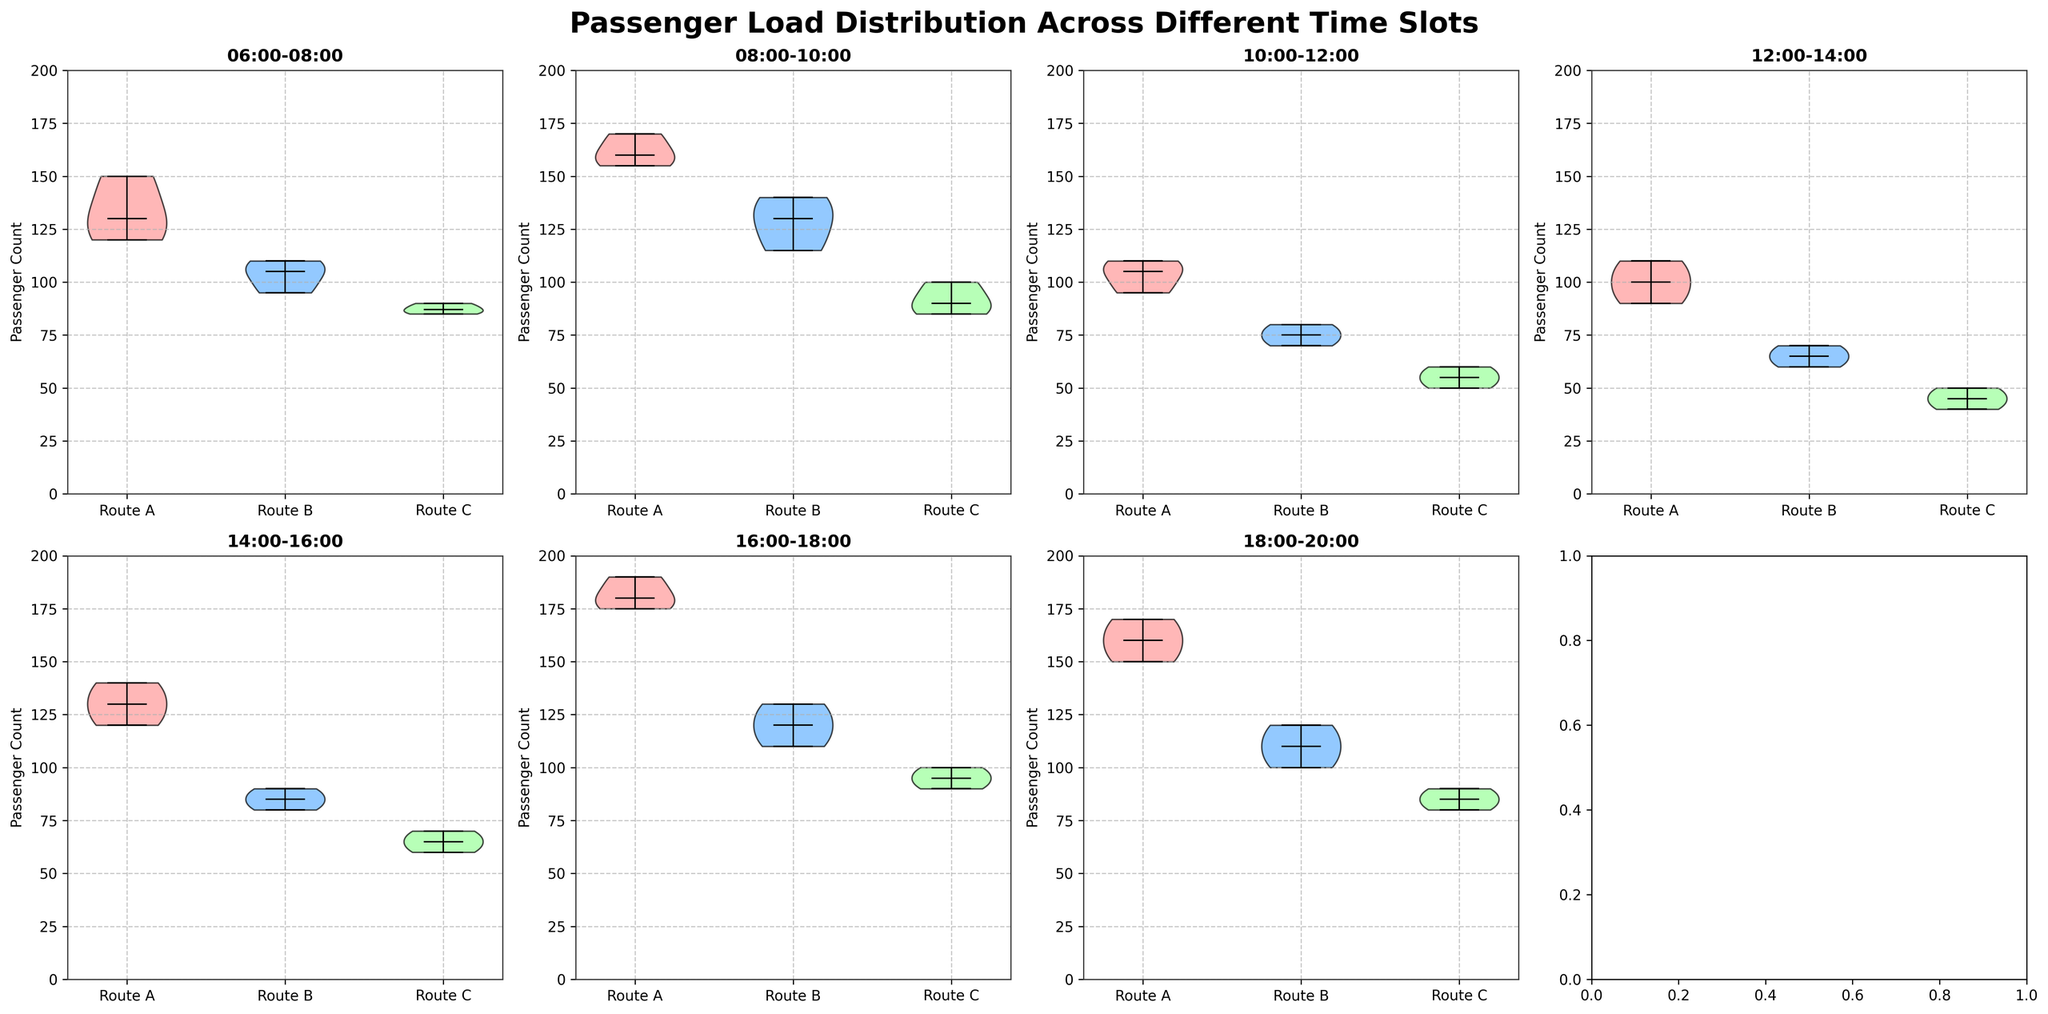What is the title of the figure? The title is positioned at the top of the figure. It clearly states the primary purpose of the visualization, which helps in understanding the context of the data being analyzed.
Answer: Passenger Load Distribution Across Different Time Slots Which time slot shows the highest passenger count for Route A? Observe the tallest violin plot for Route A across all time slots. The time slot with the highest peak represents the highest passenger count.
Answer: 16:00-18:00 How does the passenger count distribution for Route B at 08:00-10:00 compare to that at 10:00-12:00? Compare the width and height of the violin plots for Route B during these two time slots. The time slot with a higher median and wider spread records more variation and typically indicates higher passenger counts.
Answer: Lower at 10:00-12:00 than at 08:00-10:00 Which time slot has the least variability in passenger count for Route C? Look for the thinnest violin plot for Route C, which indicates less variability among the data points in that time slot.
Answer: 10:00-12:00 What is the median passenger count for Route C at 06:00-08:00? The median can be identified by the horizontal line within the violin plot for Route C at 06:00-08:00.
Answer: 87 Which route shows the most consistent passenger count across all time slots? Consistent passenger counts appear as similar-sized and shaped violin plots across the time slots, indicating low variation. Examine all plots to identify this consistency.
Answer: Route C Is there a time slot where all three routes show relatively similar median passenger counts? Find a time slot where the horizontal lines (medians) within the violin plots for all three routes are at similar levels.
Answer: 06:00-08:00 What trends do you see in passenger counts for Route A from 06:00-08:00 to 18:00-20:00? Analyze the progression of the median points and the general spread of the violin plots for Route A across all time slots to determine if counts increase, decrease, or have other patterns.
Answer: Increase initially, with peaks at 08:00-10:00 and 16:00-18:00, starting to decrease by 18:00-20:00 How does the variability of passenger counts for Route B change from 12:00-14:00 to 14:00-16:00? Compare the width of the violin plots for Route B during these two time slots. Wider plots indicate higher variability in passenger counts.
Answer: Increases For which route and time slot is the passenger count distribution the widest, indicating the highest variability? Identify the violin plot that is the widest for any given route and time slot, as this represents the highest variability in passenger counts during that period.
Answer: Route A at 16:00-18:00 